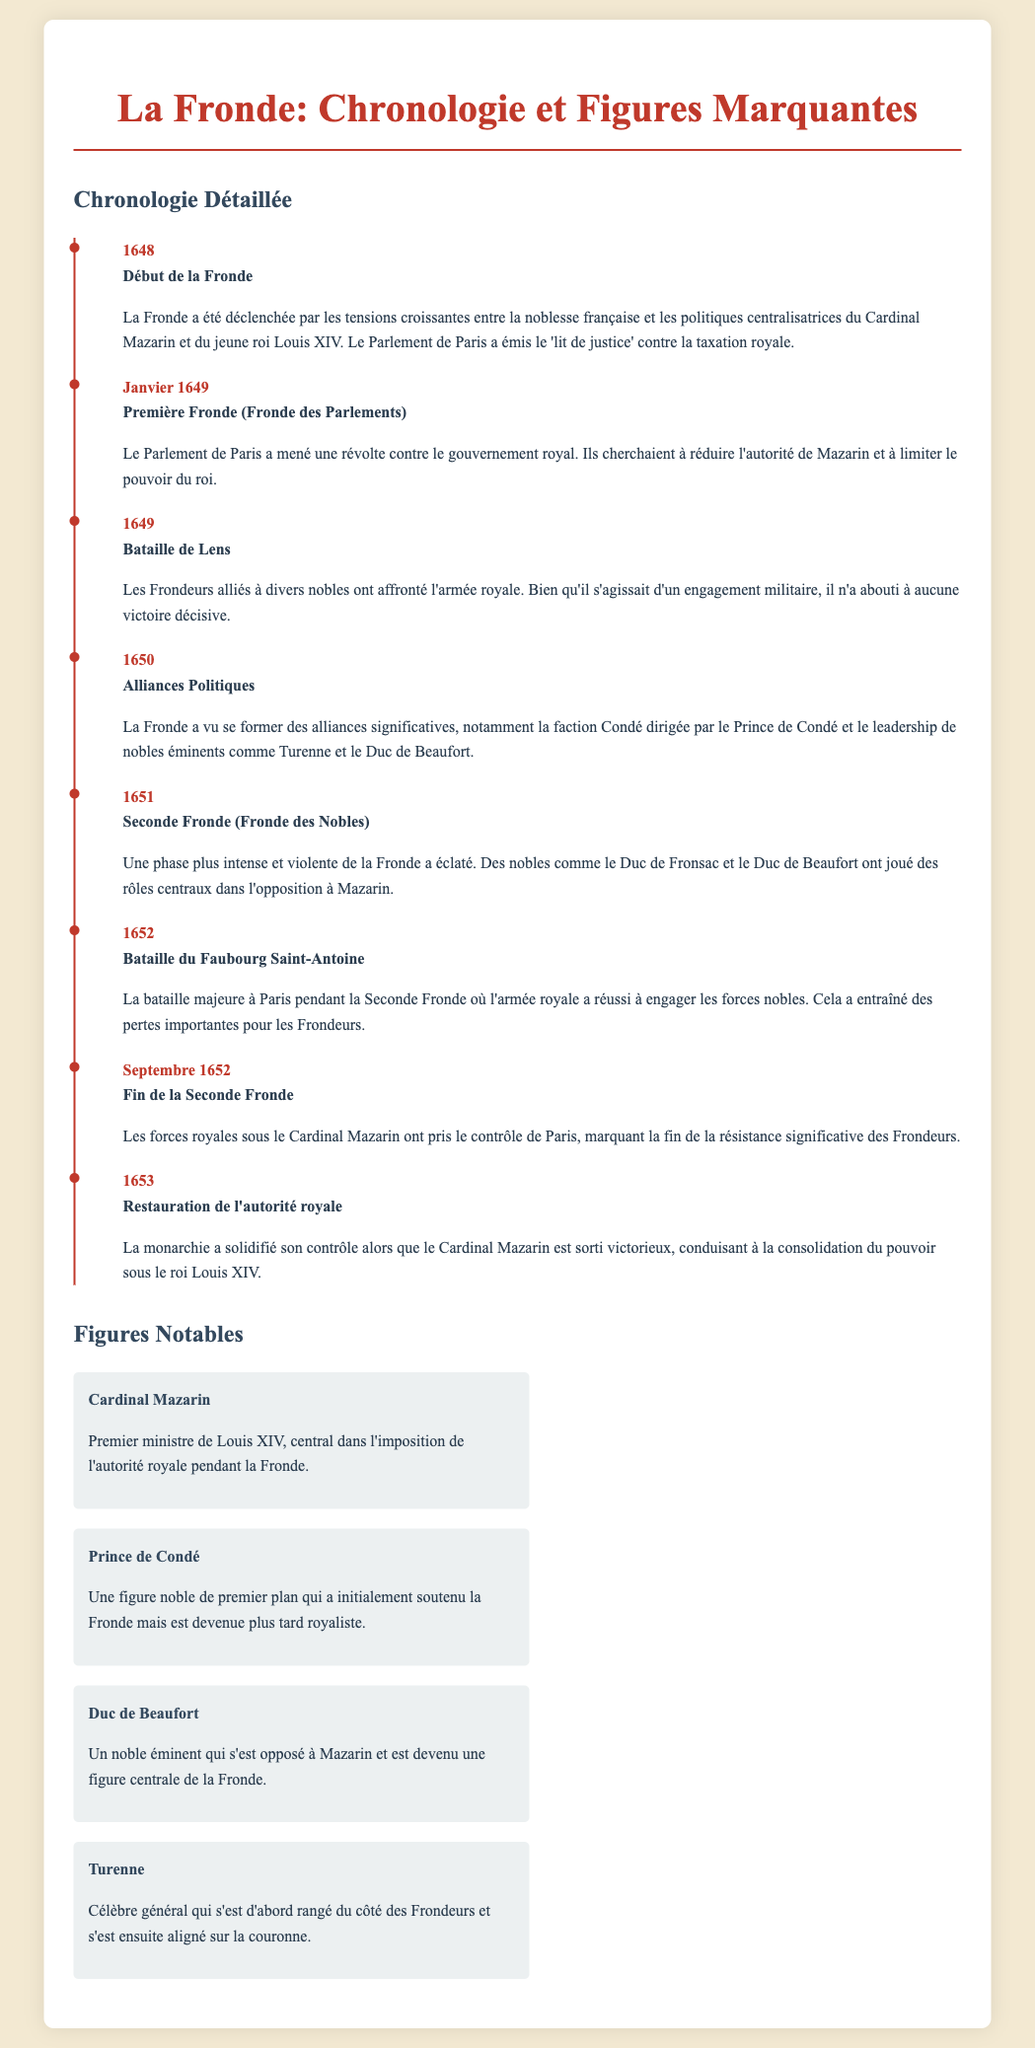Quelle est la date de début de la Fronde ? La date de début de la Fronde est mentionnée dans le document comme étant en 1648.
Answer: 1648 Quel événement majeur a eu lieu en janvier 1649 ? L'événement majeur mentionné en janvier 1649 est la Première Fronde (Fronde des Parlements).
Answer: Première Fronde (Fronde des Parlements) Qui a mené une révolte contre le gouvernement royal en 1649 ? Le Parlement de Paris a mené une révolte contre le gouvernement royal en 1649.
Answer: Parlement de Paris Quel noble a joué un rôle central dans l'opposition à Mazarin pendant la Seconde Fronde ? Le Duc de Beaufort a joué un rôle central dans l'opposition à Mazarin.
Answer: Duc de Beaufort Quelle bataille majeure a eu lieu à Paris en 1652 ? La bataille majeure à Paris en 1652 mentionnée est la Bataille du Faubourg Saint-Antoine.
Answer: Bataille du Faubourg Saint-Antoine Quel a été le résultat de la Seconde Fronde en septembre 1652 ? Le résultat de la Seconde Fronde a été la prise de contrôle de Paris par les forces royales, marquant la fin de la résistance des Frondeurs.
Answer: Fin de la résistance significative des Frondeurs Qui a été le premier ministre de Louis XIV pendant la Fronde ? Le Cardinal Mazarin a été le premier ministre de Louis XIV pendant la Fronde.
Answer: Cardinal Mazarin Quel a été l'impact de la Fronde sur l'autorité royale en 1653 ? L'impact de la Fronde en 1653 a été la restauration de l'autorité royale et la consolidation du pouvoir sous le roi Louis XIV.
Answer: Restauration de l'autorité royale 